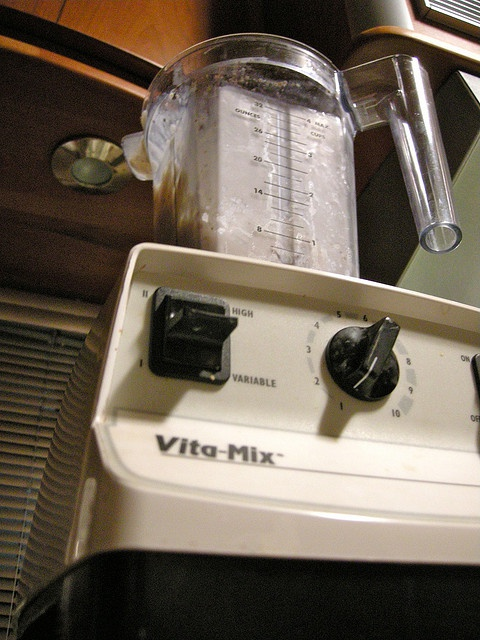Describe the objects in this image and their specific colors. I can see various objects in this image with different colors. 